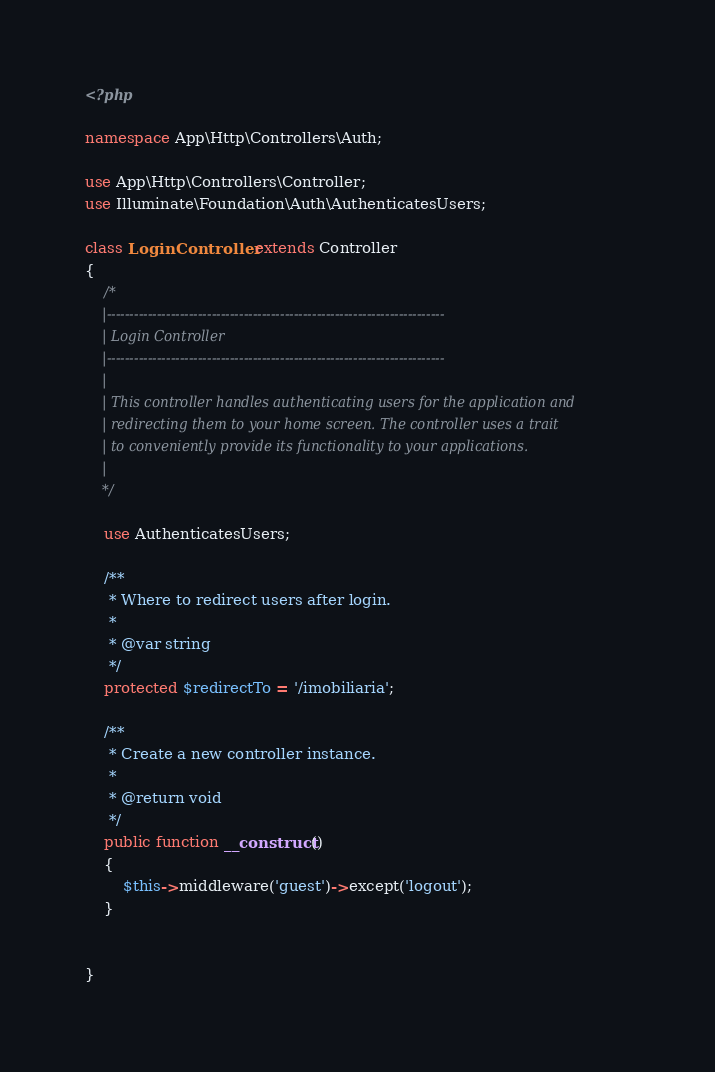<code> <loc_0><loc_0><loc_500><loc_500><_PHP_><?php

namespace App\Http\Controllers\Auth;

use App\Http\Controllers\Controller;
use Illuminate\Foundation\Auth\AuthenticatesUsers;

class LoginController extends Controller
{
    /*
    |--------------------------------------------------------------------------
    | Login Controller
    |--------------------------------------------------------------------------
    |
    | This controller handles authenticating users for the application and
    | redirecting them to your home screen. The controller uses a trait
    | to conveniently provide its functionality to your applications.
    |
    */

    use AuthenticatesUsers;

    /**
     * Where to redirect users after login.
     *
     * @var string
     */
    protected $redirectTo = '/imobiliaria';

    /**
     * Create a new controller instance.
     *
     * @return void
     */
    public function __construct()
    {
        $this->middleware('guest')->except('logout');
    }

    
}
</code> 